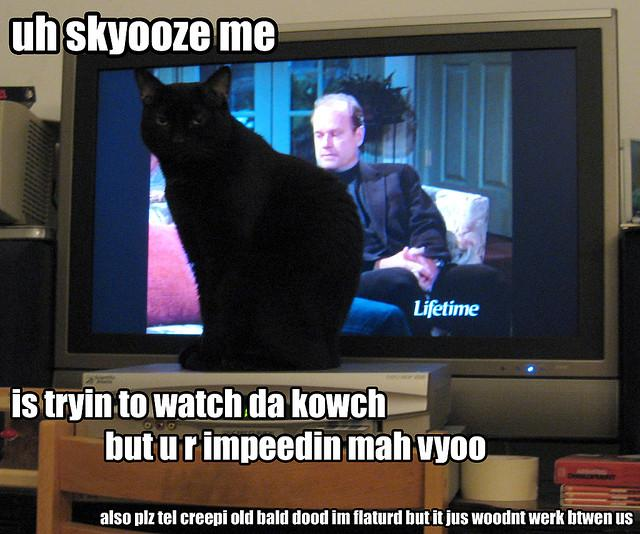What piece of furniture is misspelled here? Please explain your reasoning. couch. The only piece of furniture referenced in the caption is a couch and it is spelled wrong. 